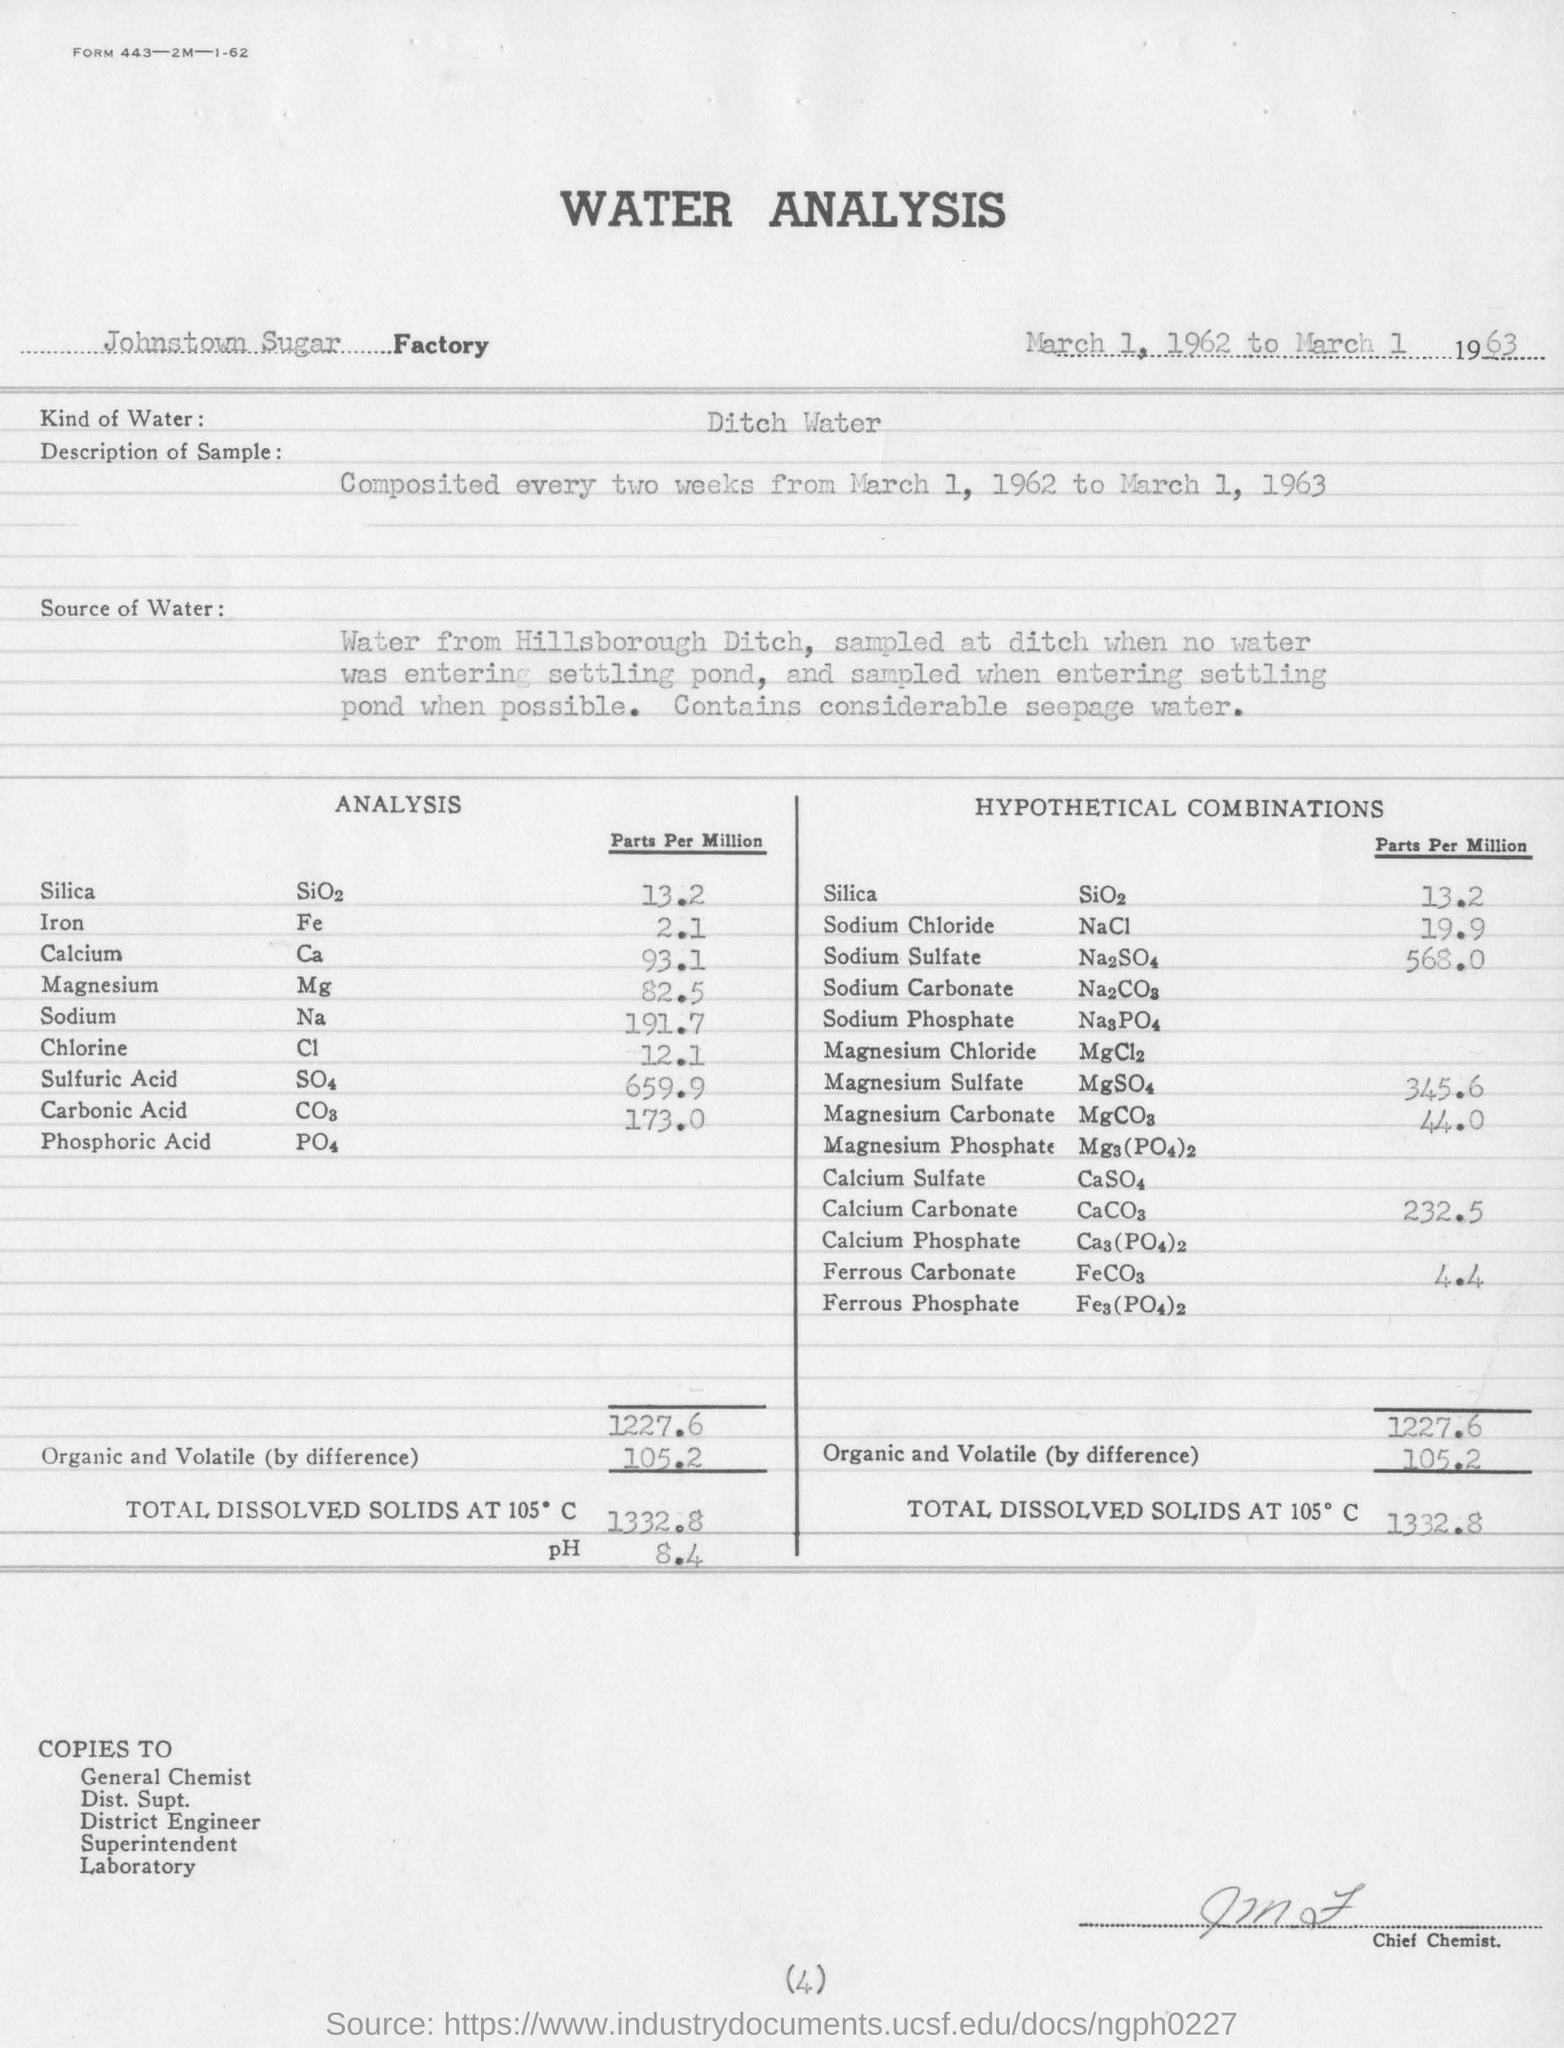Outline some significant characteristics in this image. The pH value is 8.4. The sample is collected every two weeks. 